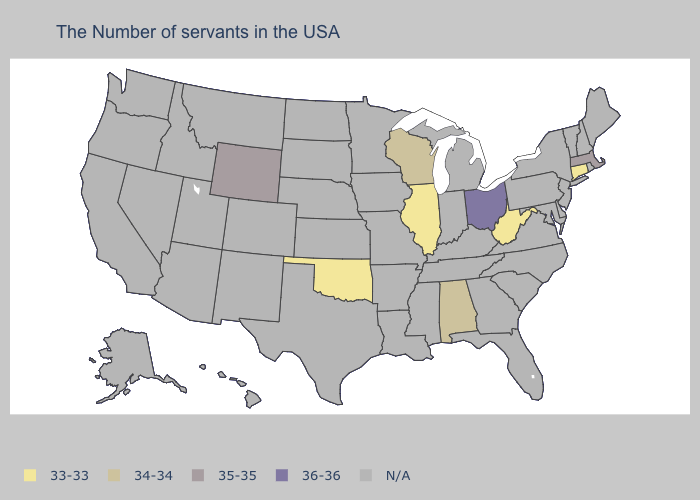What is the lowest value in the South?
Answer briefly. 33-33. Name the states that have a value in the range 33-33?
Write a very short answer. Connecticut, West Virginia, Illinois, Oklahoma. Name the states that have a value in the range 34-34?
Concise answer only. Alabama, Wisconsin. What is the value of Rhode Island?
Be succinct. N/A. What is the highest value in the Northeast ?
Short answer required. 35-35. Name the states that have a value in the range 33-33?
Concise answer only. Connecticut, West Virginia, Illinois, Oklahoma. Name the states that have a value in the range 33-33?
Be succinct. Connecticut, West Virginia, Illinois, Oklahoma. Name the states that have a value in the range 36-36?
Give a very brief answer. Ohio. Which states have the lowest value in the USA?
Answer briefly. Connecticut, West Virginia, Illinois, Oklahoma. Name the states that have a value in the range 34-34?
Quick response, please. Alabama, Wisconsin. What is the value of Arkansas?
Be succinct. N/A. What is the lowest value in the USA?
Short answer required. 33-33. What is the value of North Carolina?
Give a very brief answer. N/A. 